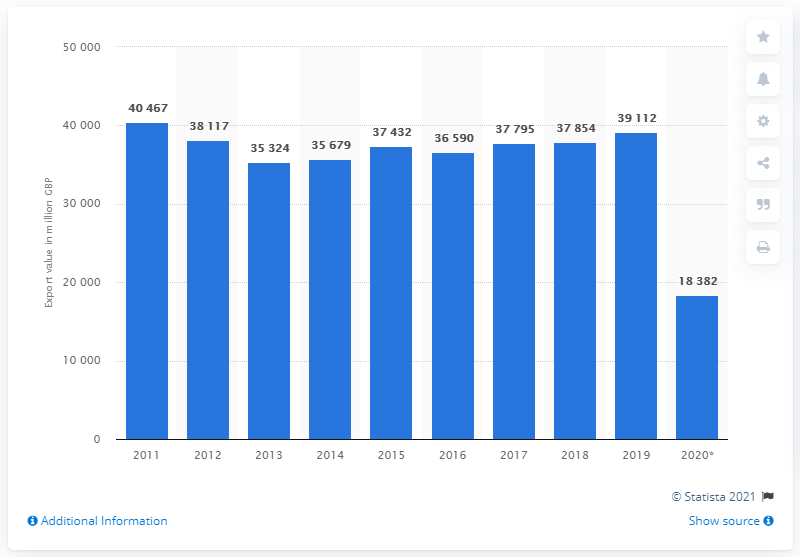List a handful of essential elements in this visual. The year 2020 experienced a significant decrease in exports. The sum of 2018 and 2019 is 76,966. In 2019, the value of England's chemical exports was 39,112. 